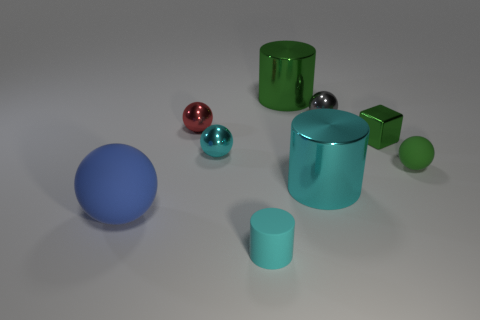Subtract all big matte balls. How many balls are left? 4 Subtract all green cylinders. How many cylinders are left? 2 Subtract 1 cubes. How many cubes are left? 0 Subtract all cylinders. How many objects are left? 6 Subtract all brown cylinders. How many gray spheres are left? 1 Subtract all tiny gray rubber objects. Subtract all small gray metal objects. How many objects are left? 8 Add 4 small gray shiny objects. How many small gray shiny objects are left? 5 Add 5 small cyan metallic balls. How many small cyan metallic balls exist? 6 Subtract 0 yellow balls. How many objects are left? 9 Subtract all brown cubes. Subtract all brown cylinders. How many cubes are left? 1 